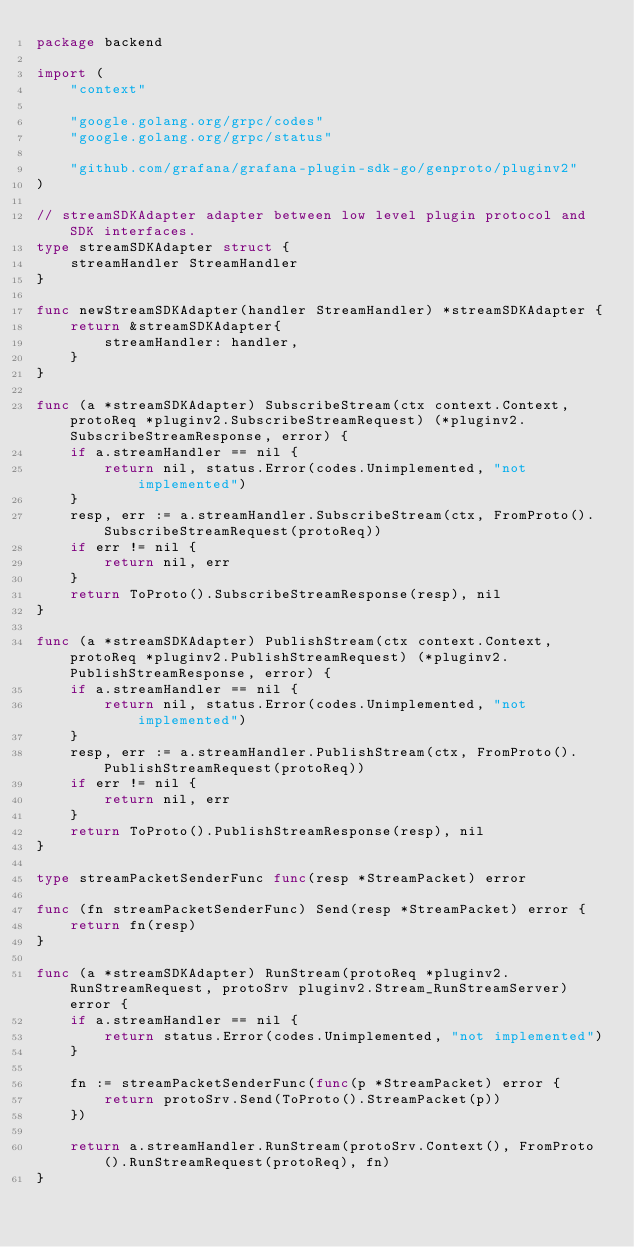<code> <loc_0><loc_0><loc_500><loc_500><_Go_>package backend

import (
	"context"

	"google.golang.org/grpc/codes"
	"google.golang.org/grpc/status"

	"github.com/grafana/grafana-plugin-sdk-go/genproto/pluginv2"
)

// streamSDKAdapter adapter between low level plugin protocol and SDK interfaces.
type streamSDKAdapter struct {
	streamHandler StreamHandler
}

func newStreamSDKAdapter(handler StreamHandler) *streamSDKAdapter {
	return &streamSDKAdapter{
		streamHandler: handler,
	}
}

func (a *streamSDKAdapter) SubscribeStream(ctx context.Context, protoReq *pluginv2.SubscribeStreamRequest) (*pluginv2.SubscribeStreamResponse, error) {
	if a.streamHandler == nil {
		return nil, status.Error(codes.Unimplemented, "not implemented")
	}
	resp, err := a.streamHandler.SubscribeStream(ctx, FromProto().SubscribeStreamRequest(protoReq))
	if err != nil {
		return nil, err
	}
	return ToProto().SubscribeStreamResponse(resp), nil
}

func (a *streamSDKAdapter) PublishStream(ctx context.Context, protoReq *pluginv2.PublishStreamRequest) (*pluginv2.PublishStreamResponse, error) {
	if a.streamHandler == nil {
		return nil, status.Error(codes.Unimplemented, "not implemented")
	}
	resp, err := a.streamHandler.PublishStream(ctx, FromProto().PublishStreamRequest(protoReq))
	if err != nil {
		return nil, err
	}
	return ToProto().PublishStreamResponse(resp), nil
}

type streamPacketSenderFunc func(resp *StreamPacket) error

func (fn streamPacketSenderFunc) Send(resp *StreamPacket) error {
	return fn(resp)
}

func (a *streamSDKAdapter) RunStream(protoReq *pluginv2.RunStreamRequest, protoSrv pluginv2.Stream_RunStreamServer) error {
	if a.streamHandler == nil {
		return status.Error(codes.Unimplemented, "not implemented")
	}

	fn := streamPacketSenderFunc(func(p *StreamPacket) error {
		return protoSrv.Send(ToProto().StreamPacket(p))
	})

	return a.streamHandler.RunStream(protoSrv.Context(), FromProto().RunStreamRequest(protoReq), fn)
}
</code> 